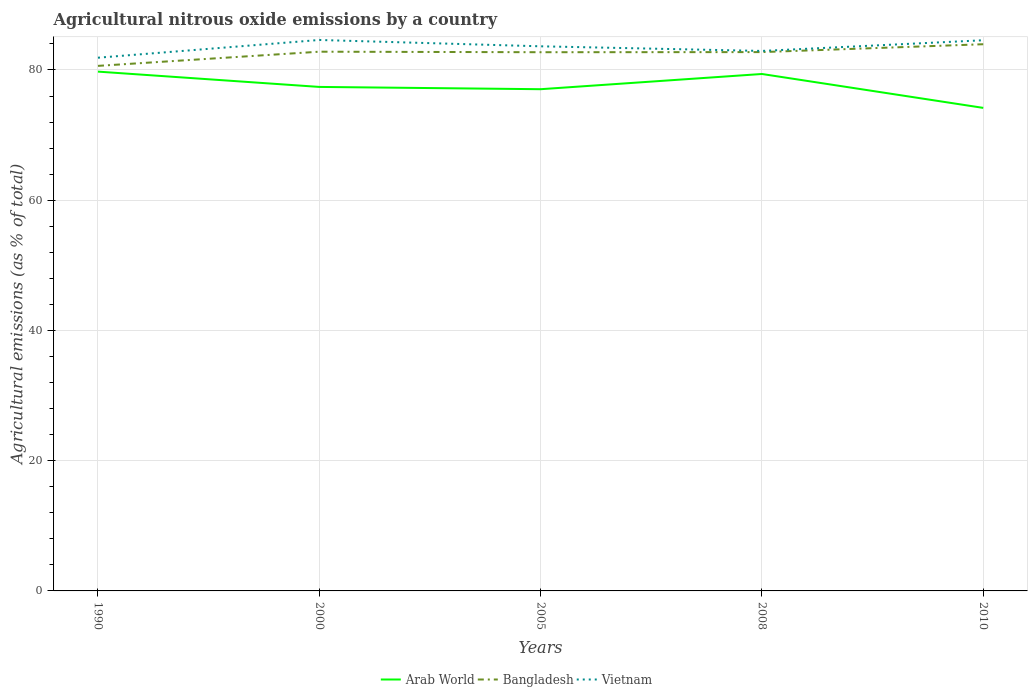Across all years, what is the maximum amount of agricultural nitrous oxide emitted in Arab World?
Keep it short and to the point. 74.18. In which year was the amount of agricultural nitrous oxide emitted in Arab World maximum?
Give a very brief answer. 2010. What is the total amount of agricultural nitrous oxide emitted in Bangladesh in the graph?
Offer a terse response. -1.23. What is the difference between the highest and the second highest amount of agricultural nitrous oxide emitted in Arab World?
Make the answer very short. 5.57. Is the amount of agricultural nitrous oxide emitted in Vietnam strictly greater than the amount of agricultural nitrous oxide emitted in Bangladesh over the years?
Your response must be concise. No. What is the difference between two consecutive major ticks on the Y-axis?
Ensure brevity in your answer.  20. Does the graph contain any zero values?
Your answer should be very brief. No. Does the graph contain grids?
Your answer should be very brief. Yes. Where does the legend appear in the graph?
Give a very brief answer. Bottom center. What is the title of the graph?
Your answer should be very brief. Agricultural nitrous oxide emissions by a country. Does "Haiti" appear as one of the legend labels in the graph?
Your answer should be very brief. No. What is the label or title of the X-axis?
Your answer should be very brief. Years. What is the label or title of the Y-axis?
Your answer should be compact. Agricultural emissions (as % of total). What is the Agricultural emissions (as % of total) in Arab World in 1990?
Provide a short and direct response. 79.75. What is the Agricultural emissions (as % of total) in Bangladesh in 1990?
Give a very brief answer. 80.63. What is the Agricultural emissions (as % of total) of Vietnam in 1990?
Your response must be concise. 81.89. What is the Agricultural emissions (as % of total) of Arab World in 2000?
Your answer should be very brief. 77.4. What is the Agricultural emissions (as % of total) in Bangladesh in 2000?
Offer a very short reply. 82.81. What is the Agricultural emissions (as % of total) of Vietnam in 2000?
Ensure brevity in your answer.  84.61. What is the Agricultural emissions (as % of total) of Arab World in 2005?
Offer a terse response. 77.05. What is the Agricultural emissions (as % of total) of Bangladesh in 2005?
Offer a terse response. 82.73. What is the Agricultural emissions (as % of total) in Vietnam in 2005?
Your answer should be very brief. 83.64. What is the Agricultural emissions (as % of total) of Arab World in 2008?
Offer a very short reply. 79.39. What is the Agricultural emissions (as % of total) of Bangladesh in 2008?
Your answer should be very brief. 82.75. What is the Agricultural emissions (as % of total) of Vietnam in 2008?
Make the answer very short. 82.93. What is the Agricultural emissions (as % of total) of Arab World in 2010?
Offer a very short reply. 74.18. What is the Agricultural emissions (as % of total) of Bangladesh in 2010?
Your answer should be compact. 83.96. What is the Agricultural emissions (as % of total) of Vietnam in 2010?
Provide a succinct answer. 84.57. Across all years, what is the maximum Agricultural emissions (as % of total) of Arab World?
Your response must be concise. 79.75. Across all years, what is the maximum Agricultural emissions (as % of total) in Bangladesh?
Provide a short and direct response. 83.96. Across all years, what is the maximum Agricultural emissions (as % of total) in Vietnam?
Your answer should be very brief. 84.61. Across all years, what is the minimum Agricultural emissions (as % of total) in Arab World?
Your answer should be compact. 74.18. Across all years, what is the minimum Agricultural emissions (as % of total) in Bangladesh?
Your answer should be very brief. 80.63. Across all years, what is the minimum Agricultural emissions (as % of total) of Vietnam?
Keep it short and to the point. 81.89. What is the total Agricultural emissions (as % of total) of Arab World in the graph?
Offer a very short reply. 387.77. What is the total Agricultural emissions (as % of total) of Bangladesh in the graph?
Offer a very short reply. 412.87. What is the total Agricultural emissions (as % of total) in Vietnam in the graph?
Provide a succinct answer. 417.63. What is the difference between the Agricultural emissions (as % of total) of Arab World in 1990 and that in 2000?
Your answer should be very brief. 2.35. What is the difference between the Agricultural emissions (as % of total) of Bangladesh in 1990 and that in 2000?
Provide a succinct answer. -2.18. What is the difference between the Agricultural emissions (as % of total) of Vietnam in 1990 and that in 2000?
Offer a very short reply. -2.72. What is the difference between the Agricultural emissions (as % of total) of Arab World in 1990 and that in 2005?
Provide a succinct answer. 2.7. What is the difference between the Agricultural emissions (as % of total) in Bangladesh in 1990 and that in 2005?
Make the answer very short. -2.1. What is the difference between the Agricultural emissions (as % of total) in Vietnam in 1990 and that in 2005?
Provide a succinct answer. -1.75. What is the difference between the Agricultural emissions (as % of total) in Arab World in 1990 and that in 2008?
Your answer should be compact. 0.36. What is the difference between the Agricultural emissions (as % of total) in Bangladesh in 1990 and that in 2008?
Keep it short and to the point. -2.11. What is the difference between the Agricultural emissions (as % of total) in Vietnam in 1990 and that in 2008?
Offer a terse response. -1.04. What is the difference between the Agricultural emissions (as % of total) in Arab World in 1990 and that in 2010?
Provide a succinct answer. 5.57. What is the difference between the Agricultural emissions (as % of total) of Bangladesh in 1990 and that in 2010?
Ensure brevity in your answer.  -3.32. What is the difference between the Agricultural emissions (as % of total) in Vietnam in 1990 and that in 2010?
Your response must be concise. -2.68. What is the difference between the Agricultural emissions (as % of total) in Arab World in 2000 and that in 2005?
Keep it short and to the point. 0.35. What is the difference between the Agricultural emissions (as % of total) of Bangladesh in 2000 and that in 2005?
Provide a succinct answer. 0.08. What is the difference between the Agricultural emissions (as % of total) in Vietnam in 2000 and that in 2005?
Ensure brevity in your answer.  0.97. What is the difference between the Agricultural emissions (as % of total) of Arab World in 2000 and that in 2008?
Provide a short and direct response. -1.99. What is the difference between the Agricultural emissions (as % of total) of Bangladesh in 2000 and that in 2008?
Provide a short and direct response. 0.06. What is the difference between the Agricultural emissions (as % of total) of Vietnam in 2000 and that in 2008?
Keep it short and to the point. 1.68. What is the difference between the Agricultural emissions (as % of total) in Arab World in 2000 and that in 2010?
Your answer should be very brief. 3.22. What is the difference between the Agricultural emissions (as % of total) of Bangladesh in 2000 and that in 2010?
Your answer should be compact. -1.15. What is the difference between the Agricultural emissions (as % of total) in Vietnam in 2000 and that in 2010?
Keep it short and to the point. 0.04. What is the difference between the Agricultural emissions (as % of total) in Arab World in 2005 and that in 2008?
Keep it short and to the point. -2.34. What is the difference between the Agricultural emissions (as % of total) in Bangladesh in 2005 and that in 2008?
Provide a short and direct response. -0.02. What is the difference between the Agricultural emissions (as % of total) in Vietnam in 2005 and that in 2008?
Offer a terse response. 0.71. What is the difference between the Agricultural emissions (as % of total) in Arab World in 2005 and that in 2010?
Your response must be concise. 2.87. What is the difference between the Agricultural emissions (as % of total) in Bangladesh in 2005 and that in 2010?
Provide a short and direct response. -1.23. What is the difference between the Agricultural emissions (as % of total) of Vietnam in 2005 and that in 2010?
Your response must be concise. -0.93. What is the difference between the Agricultural emissions (as % of total) of Arab World in 2008 and that in 2010?
Your answer should be compact. 5.21. What is the difference between the Agricultural emissions (as % of total) in Bangladesh in 2008 and that in 2010?
Ensure brevity in your answer.  -1.21. What is the difference between the Agricultural emissions (as % of total) in Vietnam in 2008 and that in 2010?
Offer a very short reply. -1.64. What is the difference between the Agricultural emissions (as % of total) in Arab World in 1990 and the Agricultural emissions (as % of total) in Bangladesh in 2000?
Provide a succinct answer. -3.06. What is the difference between the Agricultural emissions (as % of total) of Arab World in 1990 and the Agricultural emissions (as % of total) of Vietnam in 2000?
Your response must be concise. -4.86. What is the difference between the Agricultural emissions (as % of total) of Bangladesh in 1990 and the Agricultural emissions (as % of total) of Vietnam in 2000?
Your response must be concise. -3.98. What is the difference between the Agricultural emissions (as % of total) of Arab World in 1990 and the Agricultural emissions (as % of total) of Bangladesh in 2005?
Keep it short and to the point. -2.98. What is the difference between the Agricultural emissions (as % of total) in Arab World in 1990 and the Agricultural emissions (as % of total) in Vietnam in 2005?
Provide a short and direct response. -3.89. What is the difference between the Agricultural emissions (as % of total) of Bangladesh in 1990 and the Agricultural emissions (as % of total) of Vietnam in 2005?
Your response must be concise. -3. What is the difference between the Agricultural emissions (as % of total) in Arab World in 1990 and the Agricultural emissions (as % of total) in Bangladesh in 2008?
Provide a short and direct response. -3. What is the difference between the Agricultural emissions (as % of total) in Arab World in 1990 and the Agricultural emissions (as % of total) in Vietnam in 2008?
Ensure brevity in your answer.  -3.18. What is the difference between the Agricultural emissions (as % of total) of Bangladesh in 1990 and the Agricultural emissions (as % of total) of Vietnam in 2008?
Your answer should be compact. -2.29. What is the difference between the Agricultural emissions (as % of total) in Arab World in 1990 and the Agricultural emissions (as % of total) in Bangladesh in 2010?
Your answer should be compact. -4.21. What is the difference between the Agricultural emissions (as % of total) of Arab World in 1990 and the Agricultural emissions (as % of total) of Vietnam in 2010?
Offer a terse response. -4.82. What is the difference between the Agricultural emissions (as % of total) of Bangladesh in 1990 and the Agricultural emissions (as % of total) of Vietnam in 2010?
Make the answer very short. -3.93. What is the difference between the Agricultural emissions (as % of total) of Arab World in 2000 and the Agricultural emissions (as % of total) of Bangladesh in 2005?
Make the answer very short. -5.33. What is the difference between the Agricultural emissions (as % of total) in Arab World in 2000 and the Agricultural emissions (as % of total) in Vietnam in 2005?
Make the answer very short. -6.24. What is the difference between the Agricultural emissions (as % of total) in Bangladesh in 2000 and the Agricultural emissions (as % of total) in Vietnam in 2005?
Your response must be concise. -0.83. What is the difference between the Agricultural emissions (as % of total) of Arab World in 2000 and the Agricultural emissions (as % of total) of Bangladesh in 2008?
Keep it short and to the point. -5.35. What is the difference between the Agricultural emissions (as % of total) of Arab World in 2000 and the Agricultural emissions (as % of total) of Vietnam in 2008?
Ensure brevity in your answer.  -5.53. What is the difference between the Agricultural emissions (as % of total) in Bangladesh in 2000 and the Agricultural emissions (as % of total) in Vietnam in 2008?
Provide a succinct answer. -0.12. What is the difference between the Agricultural emissions (as % of total) in Arab World in 2000 and the Agricultural emissions (as % of total) in Bangladesh in 2010?
Offer a terse response. -6.55. What is the difference between the Agricultural emissions (as % of total) of Arab World in 2000 and the Agricultural emissions (as % of total) of Vietnam in 2010?
Your answer should be very brief. -7.17. What is the difference between the Agricultural emissions (as % of total) of Bangladesh in 2000 and the Agricultural emissions (as % of total) of Vietnam in 2010?
Your response must be concise. -1.76. What is the difference between the Agricultural emissions (as % of total) of Arab World in 2005 and the Agricultural emissions (as % of total) of Bangladesh in 2008?
Make the answer very short. -5.7. What is the difference between the Agricultural emissions (as % of total) of Arab World in 2005 and the Agricultural emissions (as % of total) of Vietnam in 2008?
Offer a terse response. -5.88. What is the difference between the Agricultural emissions (as % of total) in Bangladesh in 2005 and the Agricultural emissions (as % of total) in Vietnam in 2008?
Provide a short and direct response. -0.2. What is the difference between the Agricultural emissions (as % of total) of Arab World in 2005 and the Agricultural emissions (as % of total) of Bangladesh in 2010?
Provide a succinct answer. -6.91. What is the difference between the Agricultural emissions (as % of total) in Arab World in 2005 and the Agricultural emissions (as % of total) in Vietnam in 2010?
Offer a terse response. -7.52. What is the difference between the Agricultural emissions (as % of total) in Bangladesh in 2005 and the Agricultural emissions (as % of total) in Vietnam in 2010?
Your answer should be very brief. -1.84. What is the difference between the Agricultural emissions (as % of total) of Arab World in 2008 and the Agricultural emissions (as % of total) of Bangladesh in 2010?
Offer a very short reply. -4.57. What is the difference between the Agricultural emissions (as % of total) of Arab World in 2008 and the Agricultural emissions (as % of total) of Vietnam in 2010?
Offer a very short reply. -5.18. What is the difference between the Agricultural emissions (as % of total) in Bangladesh in 2008 and the Agricultural emissions (as % of total) in Vietnam in 2010?
Offer a terse response. -1.82. What is the average Agricultural emissions (as % of total) in Arab World per year?
Ensure brevity in your answer.  77.55. What is the average Agricultural emissions (as % of total) of Bangladesh per year?
Provide a succinct answer. 82.57. What is the average Agricultural emissions (as % of total) of Vietnam per year?
Your response must be concise. 83.53. In the year 1990, what is the difference between the Agricultural emissions (as % of total) of Arab World and Agricultural emissions (as % of total) of Bangladesh?
Give a very brief answer. -0.88. In the year 1990, what is the difference between the Agricultural emissions (as % of total) in Arab World and Agricultural emissions (as % of total) in Vietnam?
Offer a terse response. -2.14. In the year 1990, what is the difference between the Agricultural emissions (as % of total) of Bangladesh and Agricultural emissions (as % of total) of Vietnam?
Offer a terse response. -1.25. In the year 2000, what is the difference between the Agricultural emissions (as % of total) of Arab World and Agricultural emissions (as % of total) of Bangladesh?
Your response must be concise. -5.41. In the year 2000, what is the difference between the Agricultural emissions (as % of total) in Arab World and Agricultural emissions (as % of total) in Vietnam?
Provide a short and direct response. -7.21. In the year 2000, what is the difference between the Agricultural emissions (as % of total) in Bangladesh and Agricultural emissions (as % of total) in Vietnam?
Make the answer very short. -1.8. In the year 2005, what is the difference between the Agricultural emissions (as % of total) in Arab World and Agricultural emissions (as % of total) in Bangladesh?
Give a very brief answer. -5.68. In the year 2005, what is the difference between the Agricultural emissions (as % of total) of Arab World and Agricultural emissions (as % of total) of Vietnam?
Ensure brevity in your answer.  -6.59. In the year 2005, what is the difference between the Agricultural emissions (as % of total) of Bangladesh and Agricultural emissions (as % of total) of Vietnam?
Provide a short and direct response. -0.91. In the year 2008, what is the difference between the Agricultural emissions (as % of total) in Arab World and Agricultural emissions (as % of total) in Bangladesh?
Your answer should be compact. -3.36. In the year 2008, what is the difference between the Agricultural emissions (as % of total) in Arab World and Agricultural emissions (as % of total) in Vietnam?
Provide a short and direct response. -3.54. In the year 2008, what is the difference between the Agricultural emissions (as % of total) in Bangladesh and Agricultural emissions (as % of total) in Vietnam?
Your response must be concise. -0.18. In the year 2010, what is the difference between the Agricultural emissions (as % of total) in Arab World and Agricultural emissions (as % of total) in Bangladesh?
Provide a short and direct response. -9.78. In the year 2010, what is the difference between the Agricultural emissions (as % of total) in Arab World and Agricultural emissions (as % of total) in Vietnam?
Provide a short and direct response. -10.39. In the year 2010, what is the difference between the Agricultural emissions (as % of total) of Bangladesh and Agricultural emissions (as % of total) of Vietnam?
Give a very brief answer. -0.61. What is the ratio of the Agricultural emissions (as % of total) in Arab World in 1990 to that in 2000?
Keep it short and to the point. 1.03. What is the ratio of the Agricultural emissions (as % of total) in Bangladesh in 1990 to that in 2000?
Offer a very short reply. 0.97. What is the ratio of the Agricultural emissions (as % of total) of Vietnam in 1990 to that in 2000?
Make the answer very short. 0.97. What is the ratio of the Agricultural emissions (as % of total) of Arab World in 1990 to that in 2005?
Offer a terse response. 1.03. What is the ratio of the Agricultural emissions (as % of total) in Bangladesh in 1990 to that in 2005?
Your answer should be compact. 0.97. What is the ratio of the Agricultural emissions (as % of total) of Vietnam in 1990 to that in 2005?
Keep it short and to the point. 0.98. What is the ratio of the Agricultural emissions (as % of total) in Arab World in 1990 to that in 2008?
Make the answer very short. 1. What is the ratio of the Agricultural emissions (as % of total) of Bangladesh in 1990 to that in 2008?
Offer a very short reply. 0.97. What is the ratio of the Agricultural emissions (as % of total) in Vietnam in 1990 to that in 2008?
Your answer should be compact. 0.99. What is the ratio of the Agricultural emissions (as % of total) in Arab World in 1990 to that in 2010?
Your response must be concise. 1.08. What is the ratio of the Agricultural emissions (as % of total) in Bangladesh in 1990 to that in 2010?
Your answer should be compact. 0.96. What is the ratio of the Agricultural emissions (as % of total) in Vietnam in 1990 to that in 2010?
Offer a terse response. 0.97. What is the ratio of the Agricultural emissions (as % of total) in Arab World in 2000 to that in 2005?
Make the answer very short. 1. What is the ratio of the Agricultural emissions (as % of total) in Vietnam in 2000 to that in 2005?
Your answer should be very brief. 1.01. What is the ratio of the Agricultural emissions (as % of total) of Vietnam in 2000 to that in 2008?
Ensure brevity in your answer.  1.02. What is the ratio of the Agricultural emissions (as % of total) in Arab World in 2000 to that in 2010?
Give a very brief answer. 1.04. What is the ratio of the Agricultural emissions (as % of total) in Bangladesh in 2000 to that in 2010?
Make the answer very short. 0.99. What is the ratio of the Agricultural emissions (as % of total) in Arab World in 2005 to that in 2008?
Offer a terse response. 0.97. What is the ratio of the Agricultural emissions (as % of total) in Vietnam in 2005 to that in 2008?
Provide a short and direct response. 1.01. What is the ratio of the Agricultural emissions (as % of total) of Arab World in 2005 to that in 2010?
Keep it short and to the point. 1.04. What is the ratio of the Agricultural emissions (as % of total) of Bangladesh in 2005 to that in 2010?
Give a very brief answer. 0.99. What is the ratio of the Agricultural emissions (as % of total) in Arab World in 2008 to that in 2010?
Provide a succinct answer. 1.07. What is the ratio of the Agricultural emissions (as % of total) of Bangladesh in 2008 to that in 2010?
Your response must be concise. 0.99. What is the ratio of the Agricultural emissions (as % of total) of Vietnam in 2008 to that in 2010?
Keep it short and to the point. 0.98. What is the difference between the highest and the second highest Agricultural emissions (as % of total) in Arab World?
Your answer should be very brief. 0.36. What is the difference between the highest and the second highest Agricultural emissions (as % of total) in Bangladesh?
Offer a terse response. 1.15. What is the difference between the highest and the second highest Agricultural emissions (as % of total) of Vietnam?
Your response must be concise. 0.04. What is the difference between the highest and the lowest Agricultural emissions (as % of total) in Arab World?
Your response must be concise. 5.57. What is the difference between the highest and the lowest Agricultural emissions (as % of total) in Bangladesh?
Your answer should be compact. 3.32. What is the difference between the highest and the lowest Agricultural emissions (as % of total) in Vietnam?
Offer a very short reply. 2.72. 